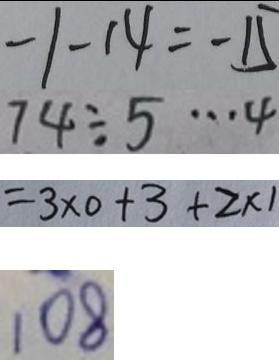<formula> <loc_0><loc_0><loc_500><loc_500>- 1 - 1 4 = - 1 5 
 7 4 \div 5 \cdots 4 
 = 3 \times 0 + 3 + 2 \times 1 
 1 0 8</formula> 